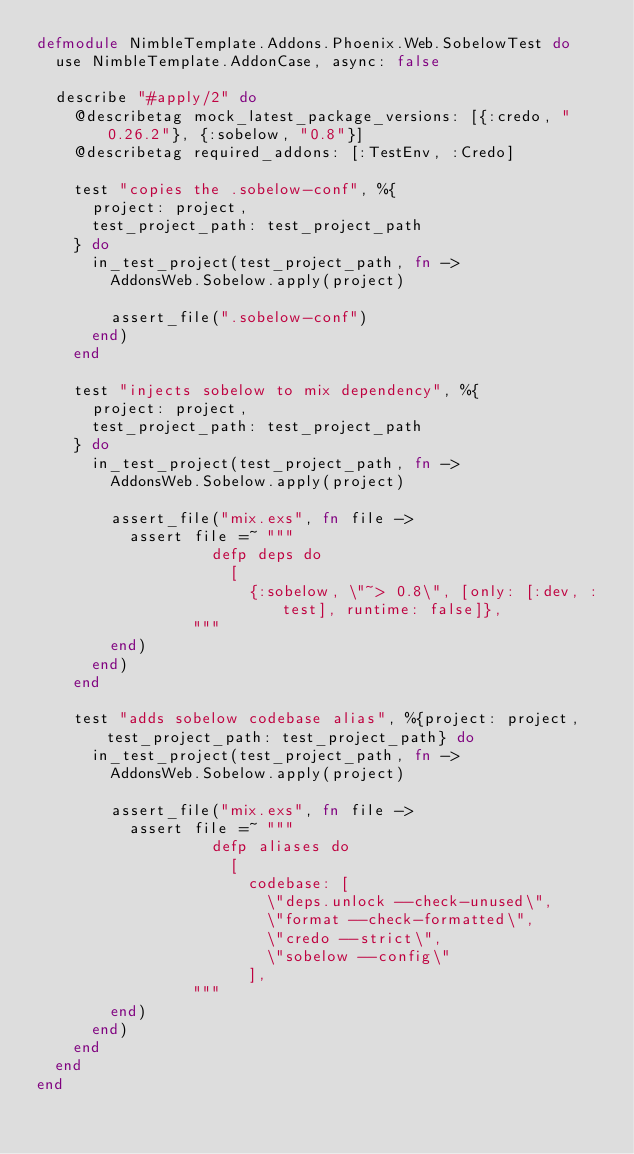<code> <loc_0><loc_0><loc_500><loc_500><_Elixir_>defmodule NimbleTemplate.Addons.Phoenix.Web.SobelowTest do
  use NimbleTemplate.AddonCase, async: false

  describe "#apply/2" do
    @describetag mock_latest_package_versions: [{:credo, "0.26.2"}, {:sobelow, "0.8"}]
    @describetag required_addons: [:TestEnv, :Credo]

    test "copies the .sobelow-conf", %{
      project: project,
      test_project_path: test_project_path
    } do
      in_test_project(test_project_path, fn ->
        AddonsWeb.Sobelow.apply(project)

        assert_file(".sobelow-conf")
      end)
    end

    test "injects sobelow to mix dependency", %{
      project: project,
      test_project_path: test_project_path
    } do
      in_test_project(test_project_path, fn ->
        AddonsWeb.Sobelow.apply(project)

        assert_file("mix.exs", fn file ->
          assert file =~ """
                   defp deps do
                     [
                       {:sobelow, \"~> 0.8\", [only: [:dev, :test], runtime: false]},
                 """
        end)
      end)
    end

    test "adds sobelow codebase alias", %{project: project, test_project_path: test_project_path} do
      in_test_project(test_project_path, fn ->
        AddonsWeb.Sobelow.apply(project)

        assert_file("mix.exs", fn file ->
          assert file =~ """
                   defp aliases do
                     [
                       codebase: [
                         \"deps.unlock --check-unused\",
                         \"format --check-formatted\",
                         \"credo --strict\",
                         \"sobelow --config\"
                       ],
                 """
        end)
      end)
    end
  end
end
</code> 